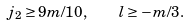Convert formula to latex. <formula><loc_0><loc_0><loc_500><loc_500>j _ { 2 } \geq 9 m / 1 0 , \quad l \geq - m / 3 .</formula> 